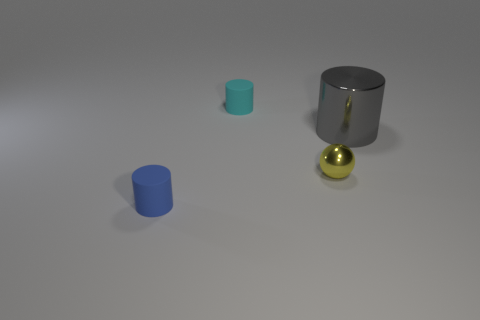Subtract 1 cylinders. How many cylinders are left? 2 Subtract all matte cylinders. How many cylinders are left? 1 Add 1 tiny blue things. How many objects exist? 5 Subtract all yellow cylinders. Subtract all blue blocks. How many cylinders are left? 3 Subtract all cylinders. How many objects are left? 1 Add 1 tiny metallic balls. How many tiny metallic balls exist? 2 Subtract 0 purple balls. How many objects are left? 4 Subtract all big gray cylinders. Subtract all cyan matte things. How many objects are left? 2 Add 4 blue matte things. How many blue matte things are left? 5 